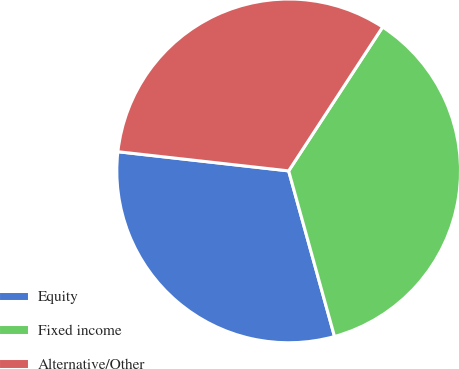Convert chart to OTSL. <chart><loc_0><loc_0><loc_500><loc_500><pie_chart><fcel>Equity<fcel>Fixed income<fcel>Alternative/Other<nl><fcel>31.08%<fcel>36.49%<fcel>32.43%<nl></chart> 